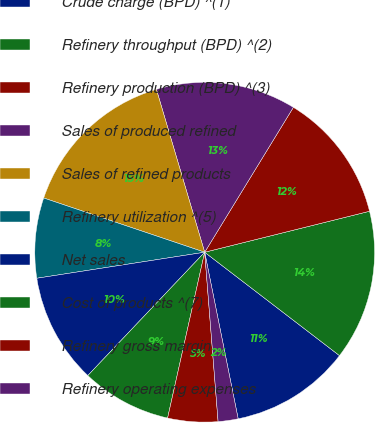Convert chart. <chart><loc_0><loc_0><loc_500><loc_500><pie_chart><fcel>Crude charge (BPD) ^(1)<fcel>Refinery throughput (BPD) ^(2)<fcel>Refinery production (BPD) ^(3)<fcel>Sales of produced refined<fcel>Sales of refined products<fcel>Refinery utilization ^(5)<fcel>Net sales<fcel>Cost of products ^(7)<fcel>Refinery gross margin<fcel>Refinery operating expenses<nl><fcel>11.43%<fcel>14.29%<fcel>12.38%<fcel>13.33%<fcel>15.24%<fcel>7.62%<fcel>10.48%<fcel>8.57%<fcel>4.76%<fcel>1.9%<nl></chart> 